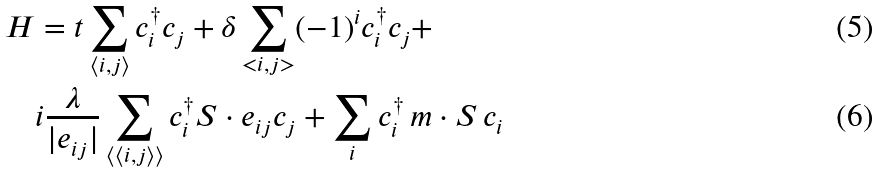<formula> <loc_0><loc_0><loc_500><loc_500>H & = t \sum _ { \langle i , j \rangle } c _ { i } ^ { \dagger } c _ { j } + \delta \sum _ { < i , j > } ( - 1 ) ^ { i } c _ { i } ^ { \dagger } c _ { j } + \\ & i \frac { \lambda } { | e _ { i j } | } \sum _ { \langle \langle i , j \rangle \rangle } c _ { i } ^ { \dagger } S \cdot e _ { i j } c _ { j } + \sum _ { i } c _ { i } ^ { \dagger } \, m \cdot S \, c _ { i }</formula> 